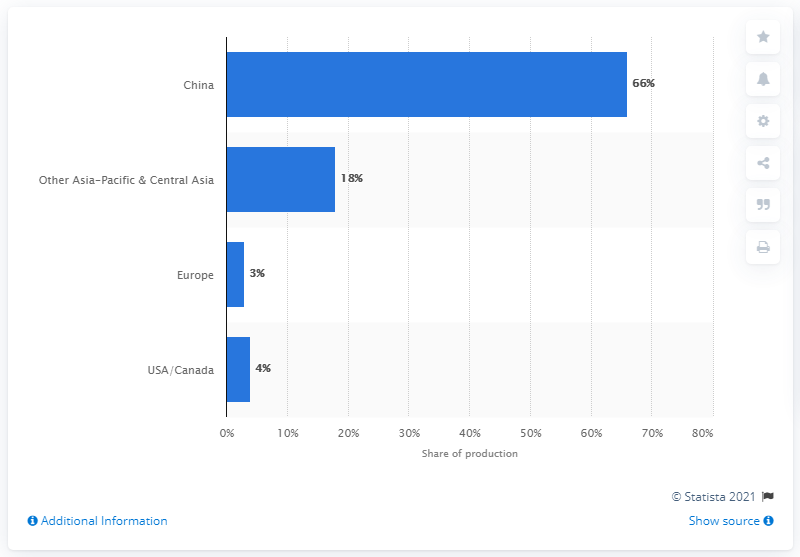Give some essential details in this illustration. In 2019, China was the leading country in the production of solar photovoltaic (PV) modules. 